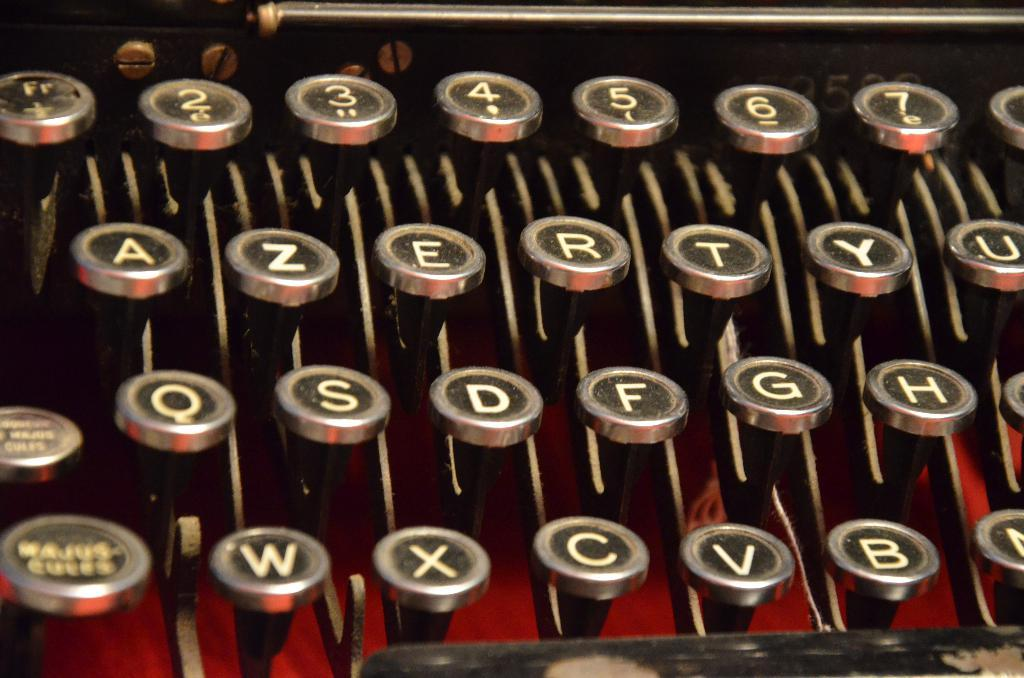<image>
Write a terse but informative summary of the picture. A old type writer displaying various letters and numbers including A, Z, E, R, T, and Y. 